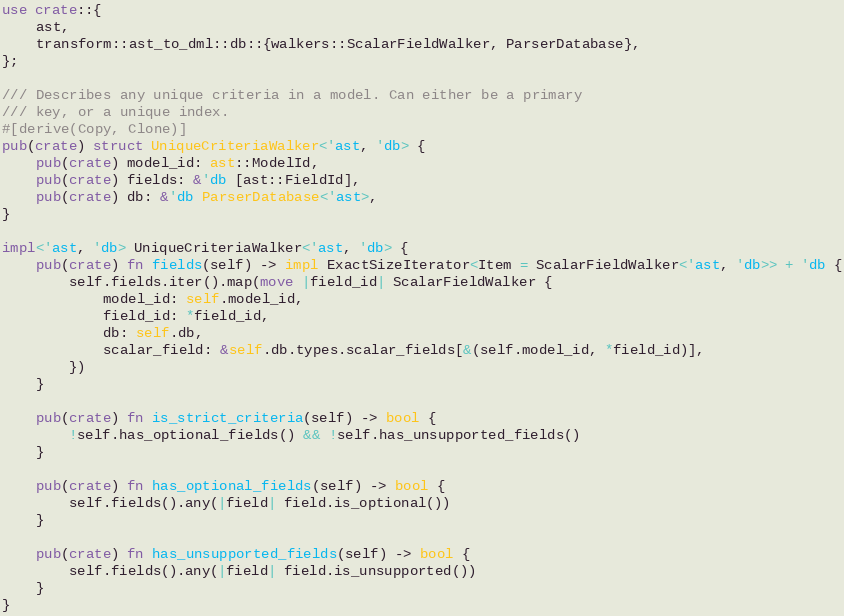Convert code to text. <code><loc_0><loc_0><loc_500><loc_500><_Rust_>use crate::{
    ast,
    transform::ast_to_dml::db::{walkers::ScalarFieldWalker, ParserDatabase},
};

/// Describes any unique criteria in a model. Can either be a primary
/// key, or a unique index.
#[derive(Copy, Clone)]
pub(crate) struct UniqueCriteriaWalker<'ast, 'db> {
    pub(crate) model_id: ast::ModelId,
    pub(crate) fields: &'db [ast::FieldId],
    pub(crate) db: &'db ParserDatabase<'ast>,
}

impl<'ast, 'db> UniqueCriteriaWalker<'ast, 'db> {
    pub(crate) fn fields(self) -> impl ExactSizeIterator<Item = ScalarFieldWalker<'ast, 'db>> + 'db {
        self.fields.iter().map(move |field_id| ScalarFieldWalker {
            model_id: self.model_id,
            field_id: *field_id,
            db: self.db,
            scalar_field: &self.db.types.scalar_fields[&(self.model_id, *field_id)],
        })
    }

    pub(crate) fn is_strict_criteria(self) -> bool {
        !self.has_optional_fields() && !self.has_unsupported_fields()
    }

    pub(crate) fn has_optional_fields(self) -> bool {
        self.fields().any(|field| field.is_optional())
    }

    pub(crate) fn has_unsupported_fields(self) -> bool {
        self.fields().any(|field| field.is_unsupported())
    }
}
</code> 